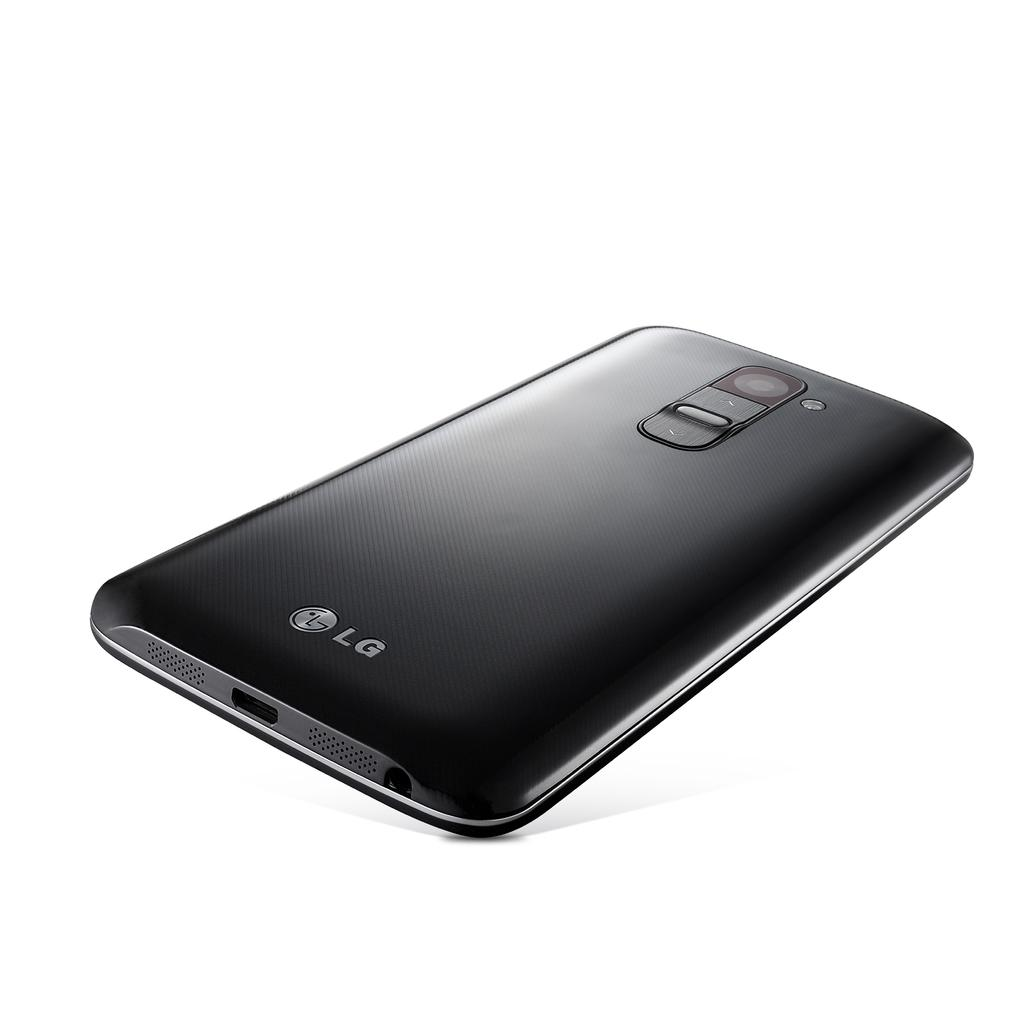Provide a one-sentence caption for the provided image. An LG phone that is black in with a plain white backdrop. 